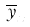Convert formula to latex. <formula><loc_0><loc_0><loc_500><loc_500>\overline { y } _ { x }</formula> 